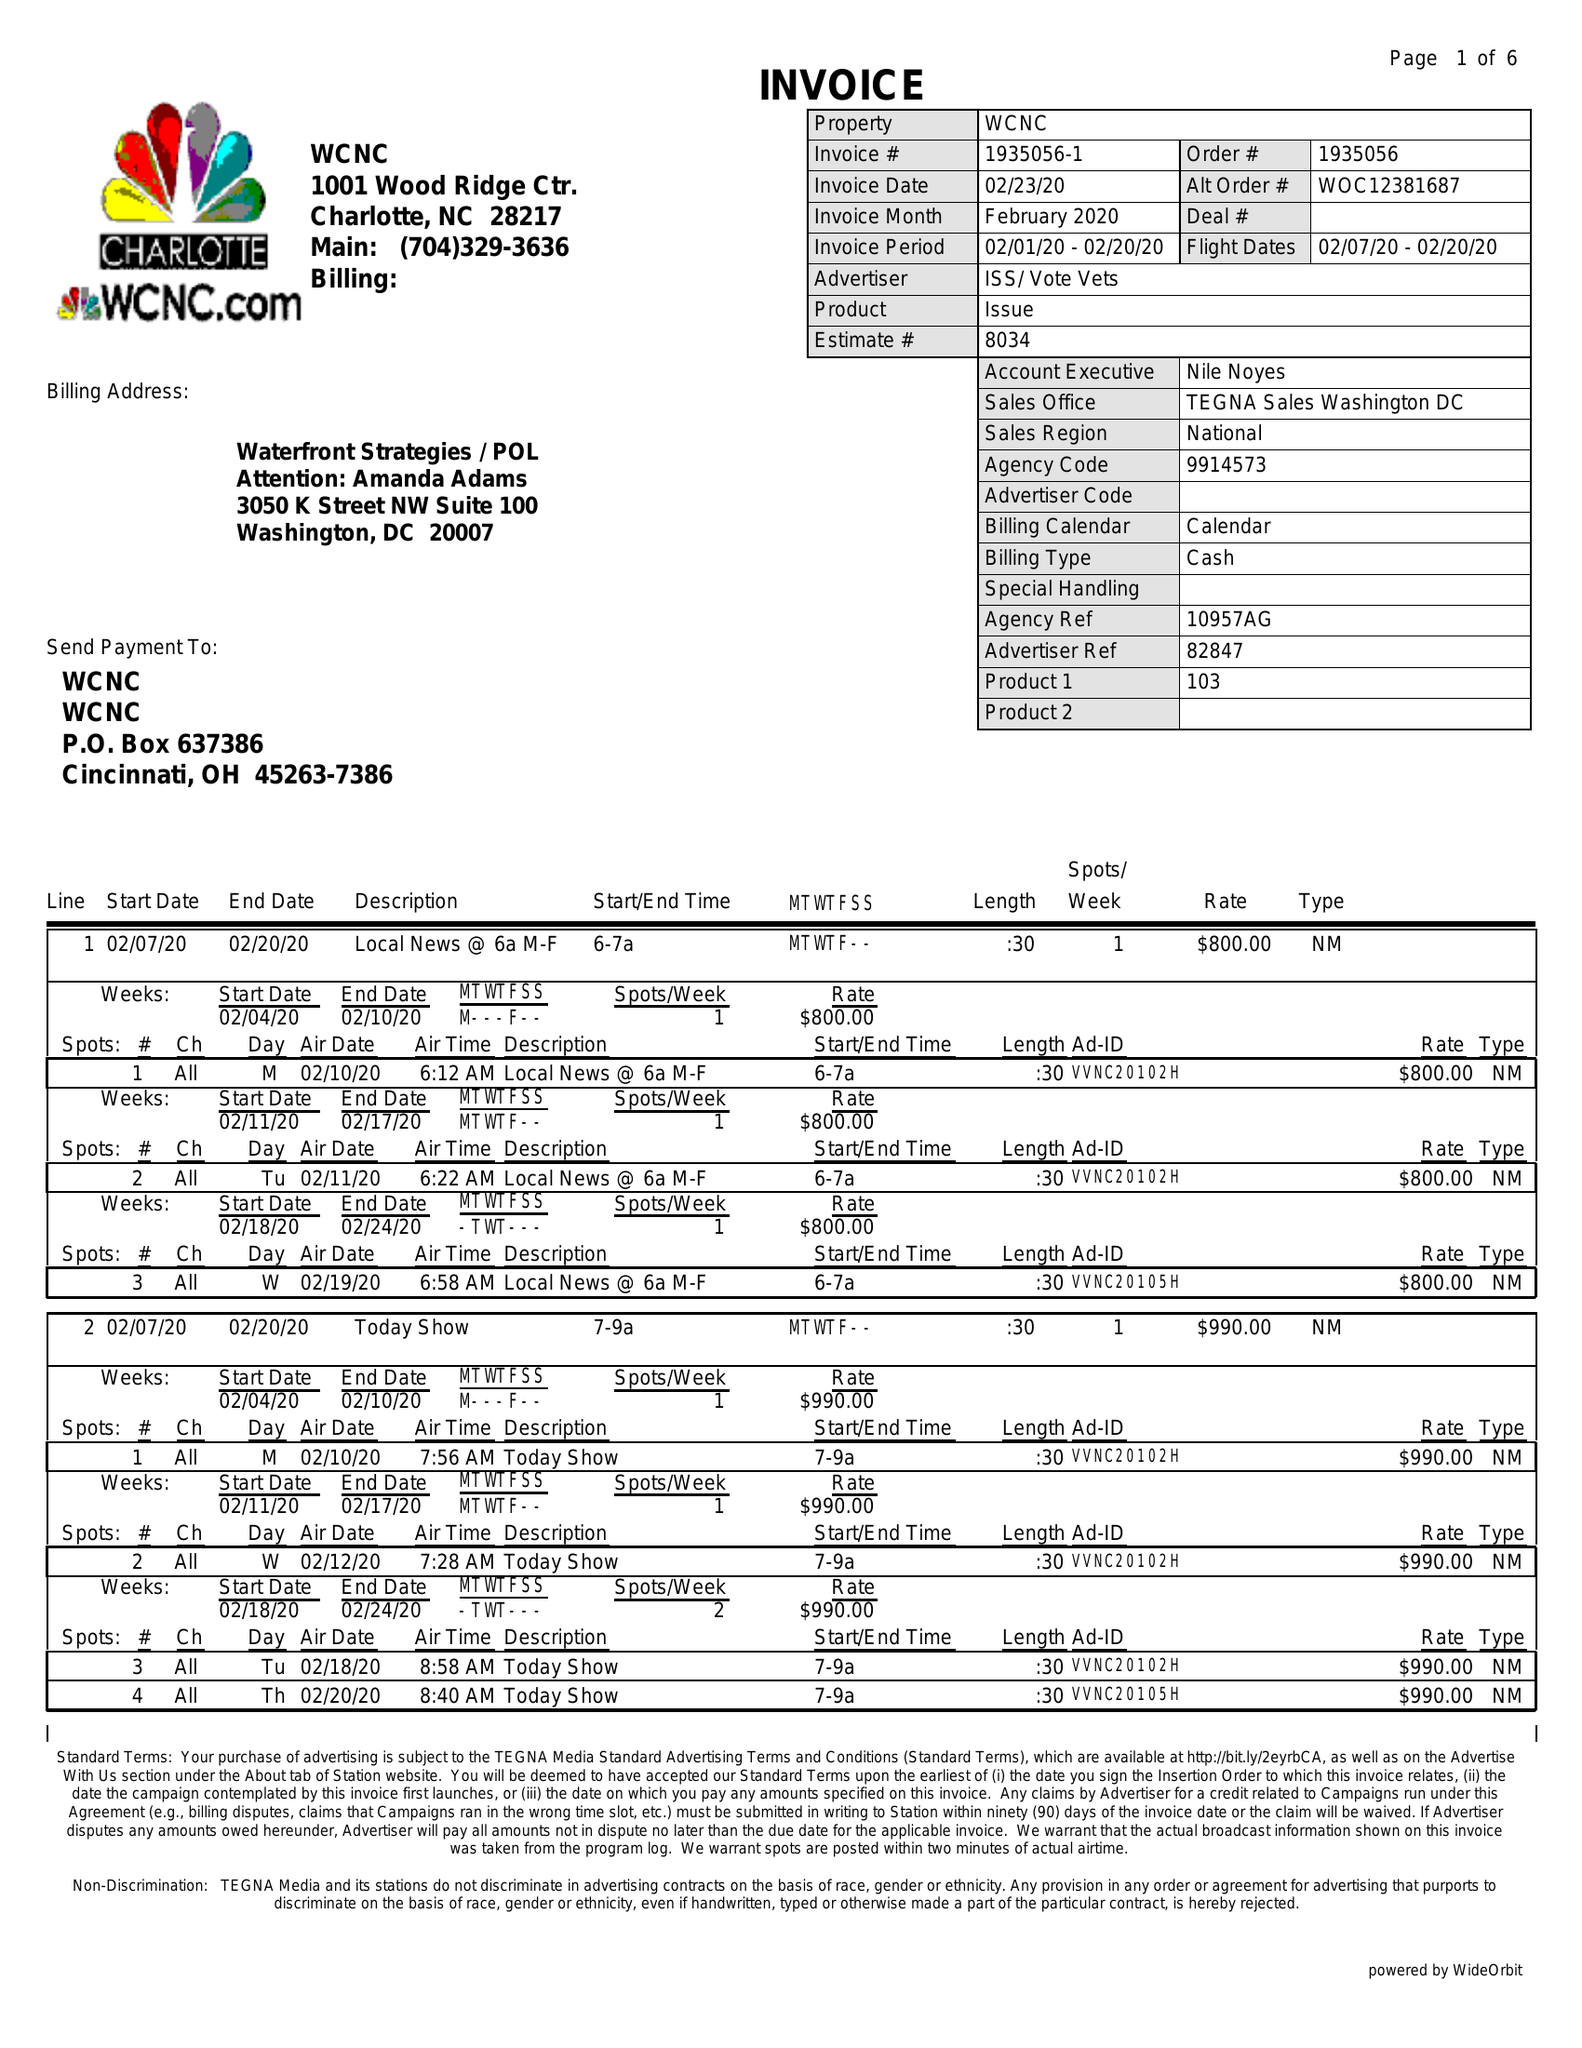What is the value for the flight_to?
Answer the question using a single word or phrase. 02/20/20 